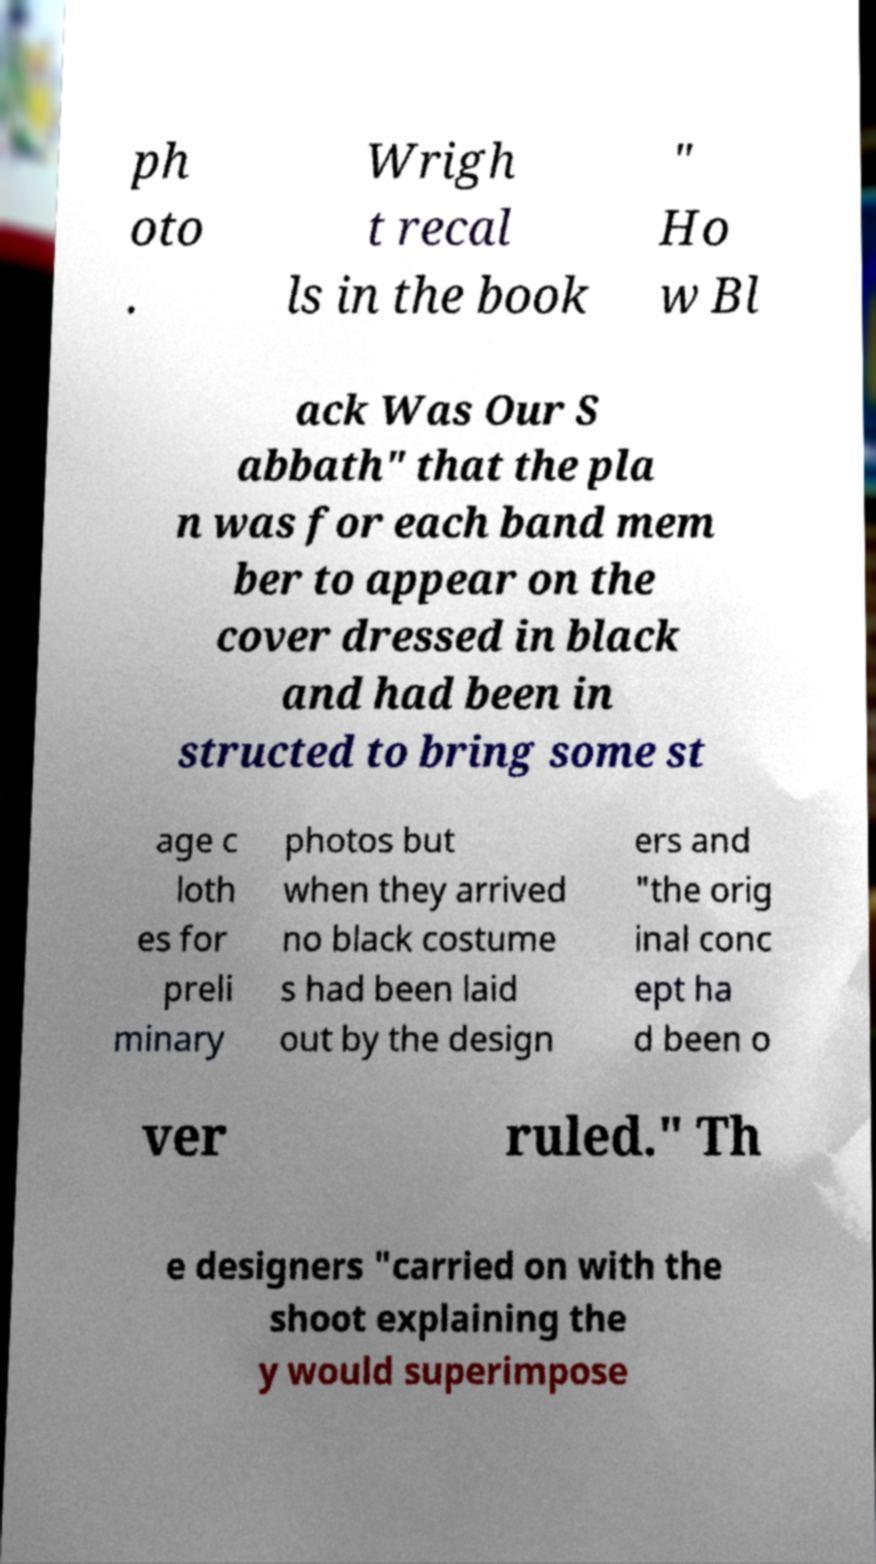There's text embedded in this image that I need extracted. Can you transcribe it verbatim? ph oto . Wrigh t recal ls in the book " Ho w Bl ack Was Our S abbath" that the pla n was for each band mem ber to appear on the cover dressed in black and had been in structed to bring some st age c loth es for preli minary photos but when they arrived no black costume s had been laid out by the design ers and "the orig inal conc ept ha d been o ver ruled." Th e designers "carried on with the shoot explaining the y would superimpose 